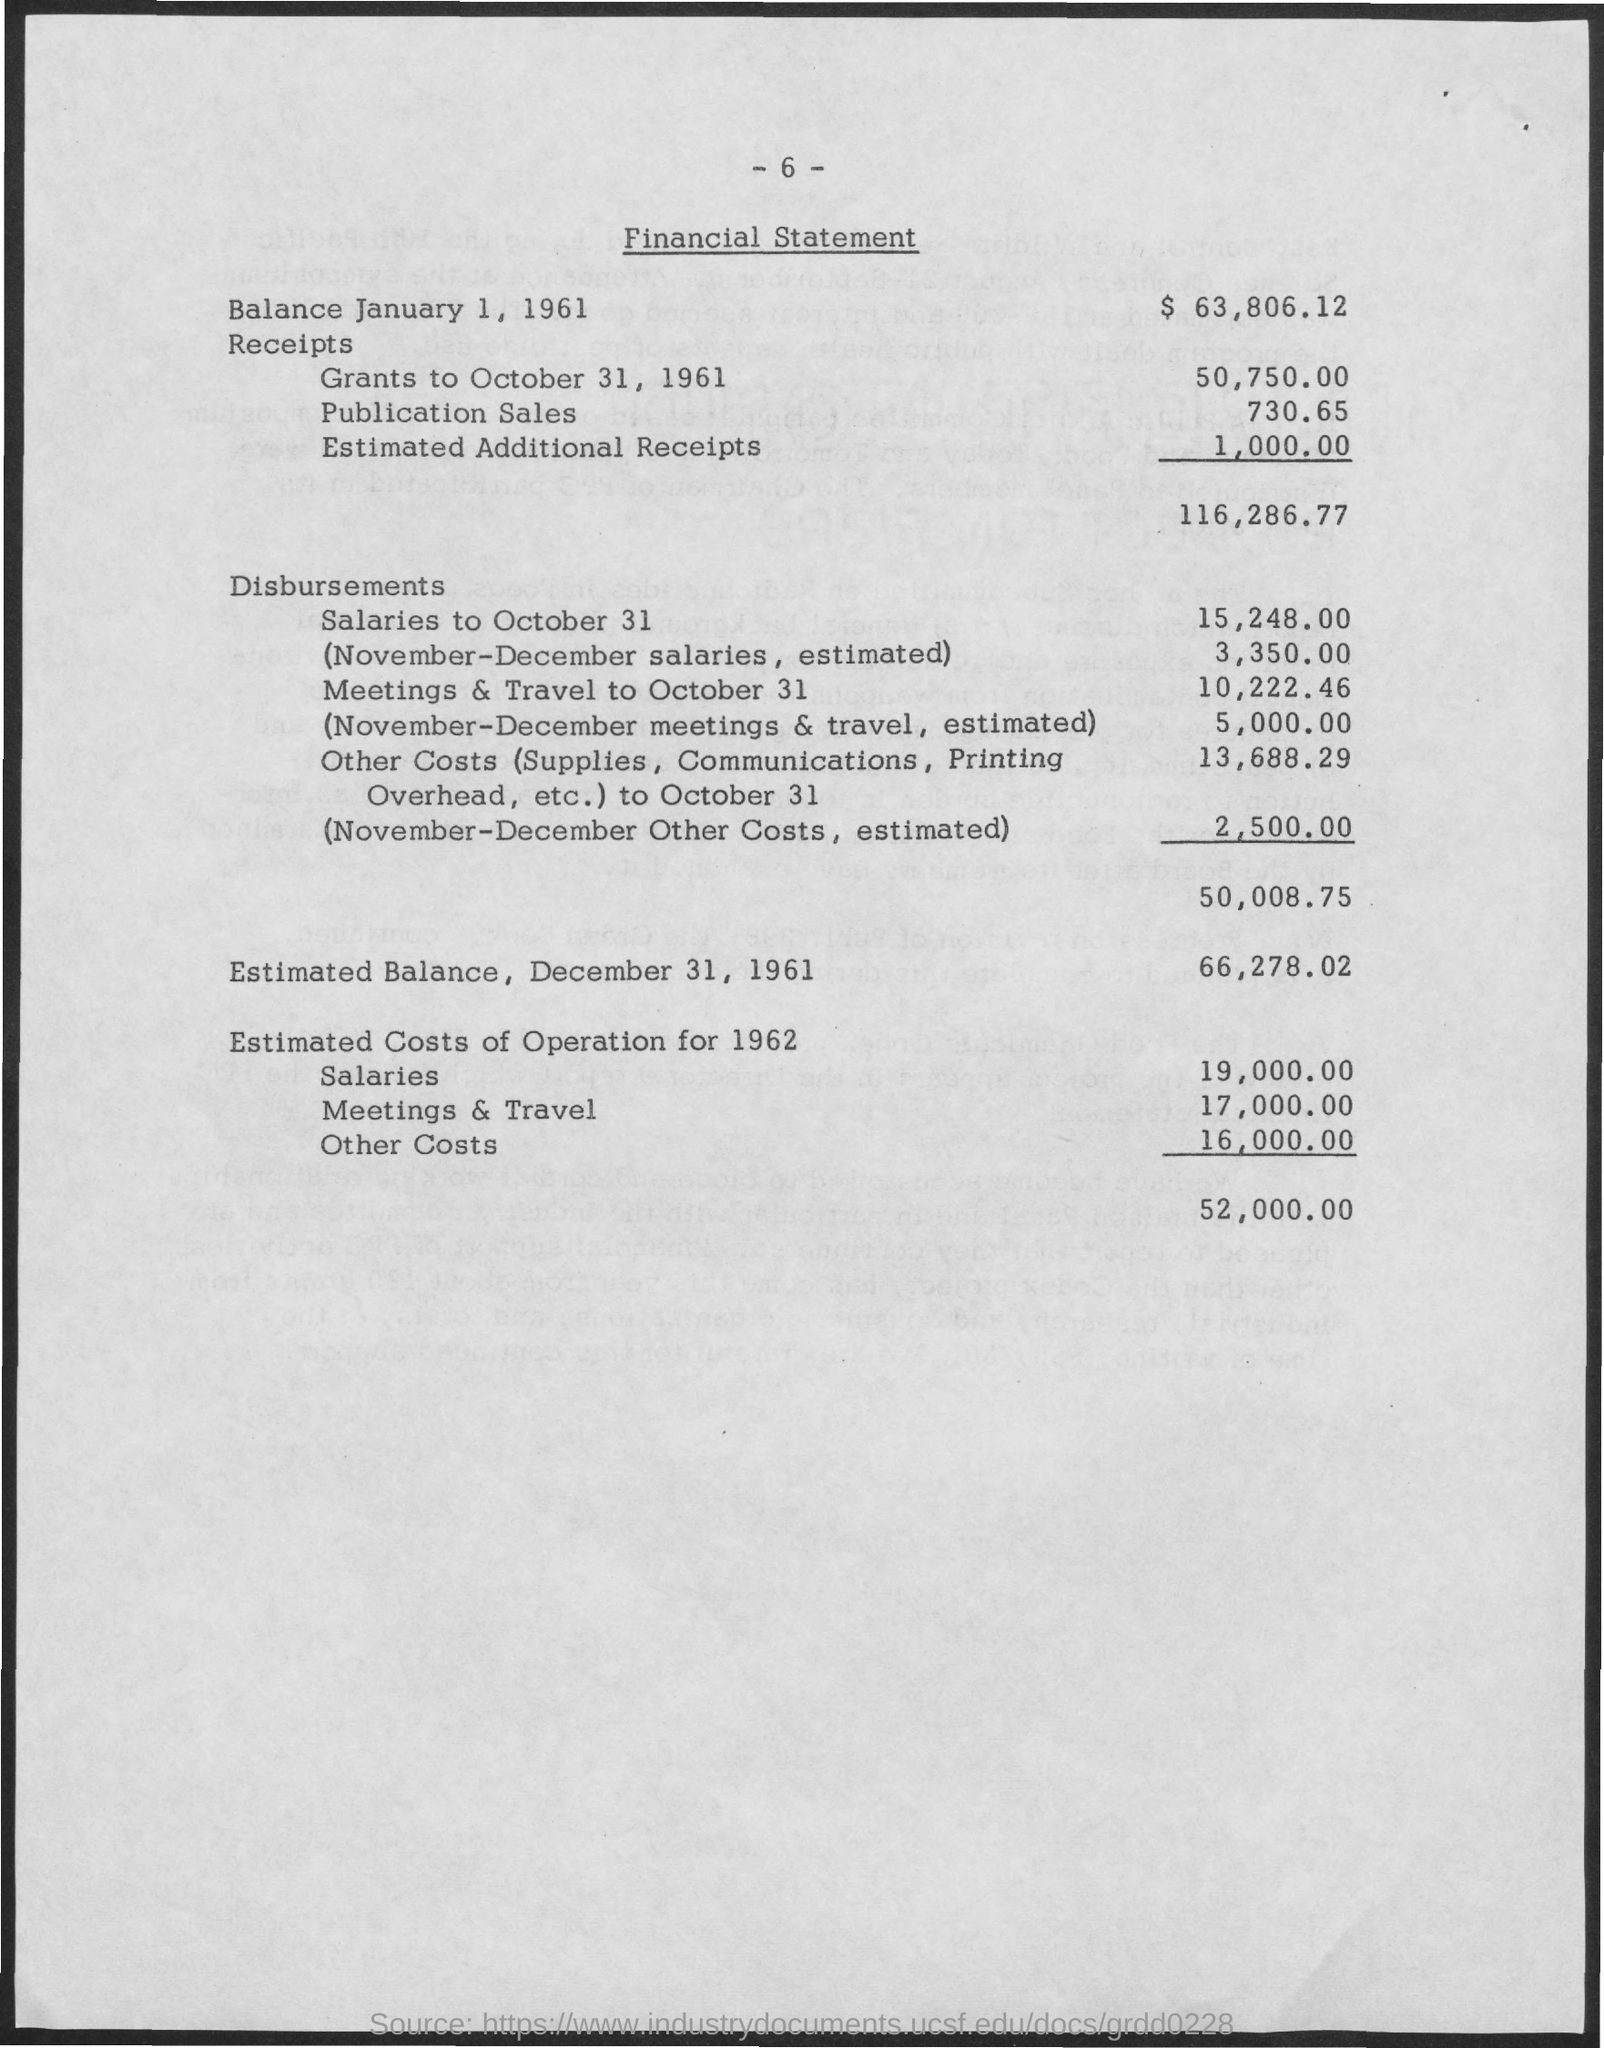What is the Balance January 1, 1961?
Provide a succinct answer. $63,806.12. What are the Disbursements for Salaries to October 31?
Ensure brevity in your answer.  15,248.00. What are the Disbursements for November-December salaries, estimated?
Make the answer very short. 3,350.00. What are the Disbursements for Meetings & travel to october 31?
Keep it short and to the point. 10,222.46. What are the Disbursements for November-December meetings & travel, estimated?
Your answer should be compact. 5,000.00. What are the Disbursements for November-December other costs, estimated?
Your answer should be very brief. 2,500.00. What are the Total Disbursements?
Provide a short and direct response. 50,008.75. What is the Estimated Balance December 31, 1961?
Ensure brevity in your answer.  66,278.02. What is the cost of receipts for grants to October 31, 1961?
Make the answer very short. 50,750. What is the cost of receipts for Publication sales?
Your answer should be very brief. 730.65. 